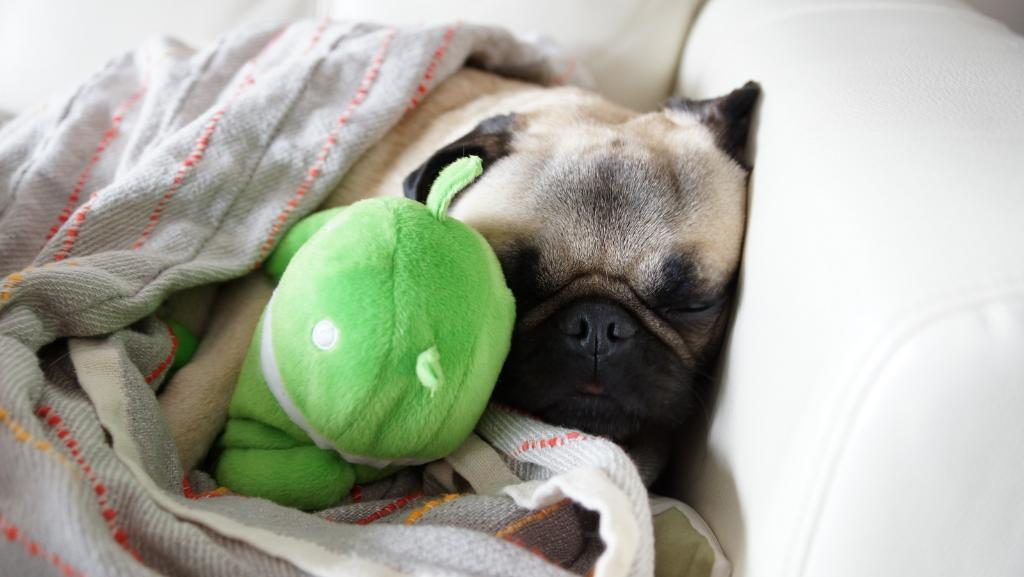What animal is present in the image? There is a dog in the image. What is the dog holding in the image? The dog is holding a toy. Where is the dog located in the image? The dog is sleeping on a sofa. What is covering the dog on the sofa? There is a blanket over the dog. What type of apples can be seen growing in the middle of the image? There are no apples present in the image. What is the relation between the dog and the sofa in the image? The dog is sleeping on the sofa, but there is no direct relation between the dog and the sofa mentioned in the facts. 